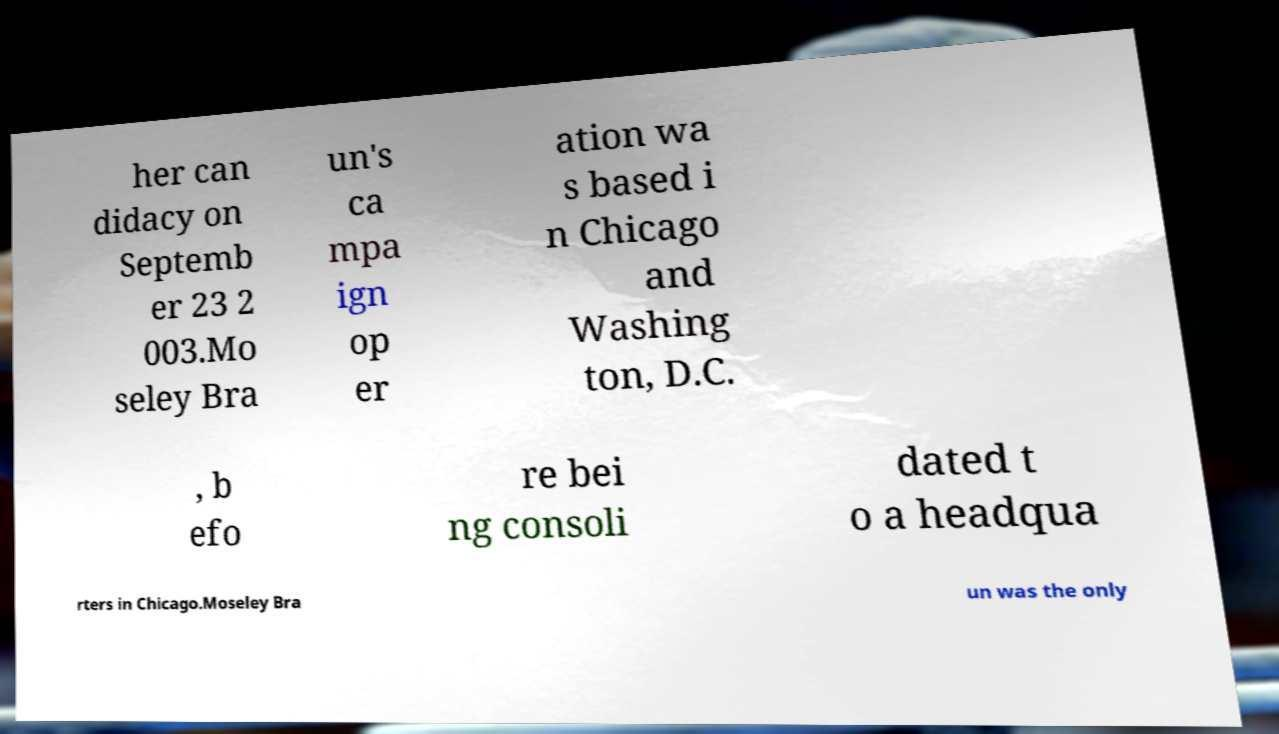I need the written content from this picture converted into text. Can you do that? her can didacy on Septemb er 23 2 003.Mo seley Bra un's ca mpa ign op er ation wa s based i n Chicago and Washing ton, D.C. , b efo re bei ng consoli dated t o a headqua rters in Chicago.Moseley Bra un was the only 